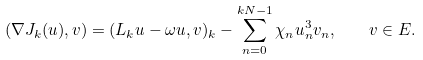Convert formula to latex. <formula><loc_0><loc_0><loc_500><loc_500>\left ( \nabla J _ { k } ( u ) , v \right ) = ( L _ { k } u - \omega u , v ) _ { k } - \sum _ { n = 0 } ^ { k N - 1 } \chi _ { n } u _ { n } ^ { 3 } v _ { n } , \quad v \in E .</formula> 